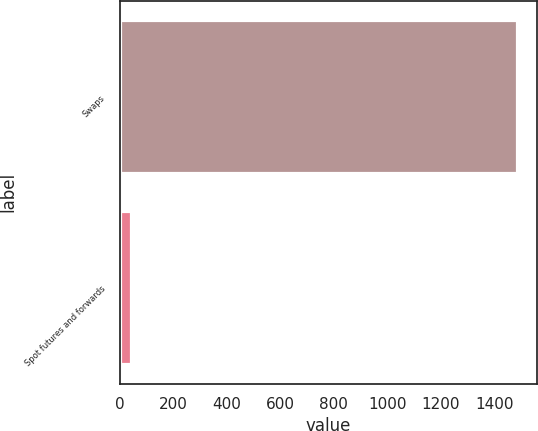Convert chart. <chart><loc_0><loc_0><loc_500><loc_500><bar_chart><fcel>Swaps<fcel>Spot futures and forwards<nl><fcel>1485.3<fcel>39.5<nl></chart> 